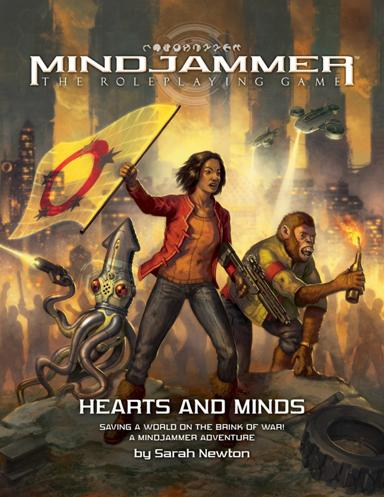Who are the characters shown on this cover, and what roles might they play in the game? The image portrays three main characters likely crucial to the storyline. The woman with the gun appears as a leader or a strong warrior, possibly a primary character players can embody or interact with. The man with the wrench suggests a mechanic or engineer role, aiding in technological aspects or equipment within the game. The alien creature might be a companion or an alien species that players encounter, offering unique interactions and challenges. 